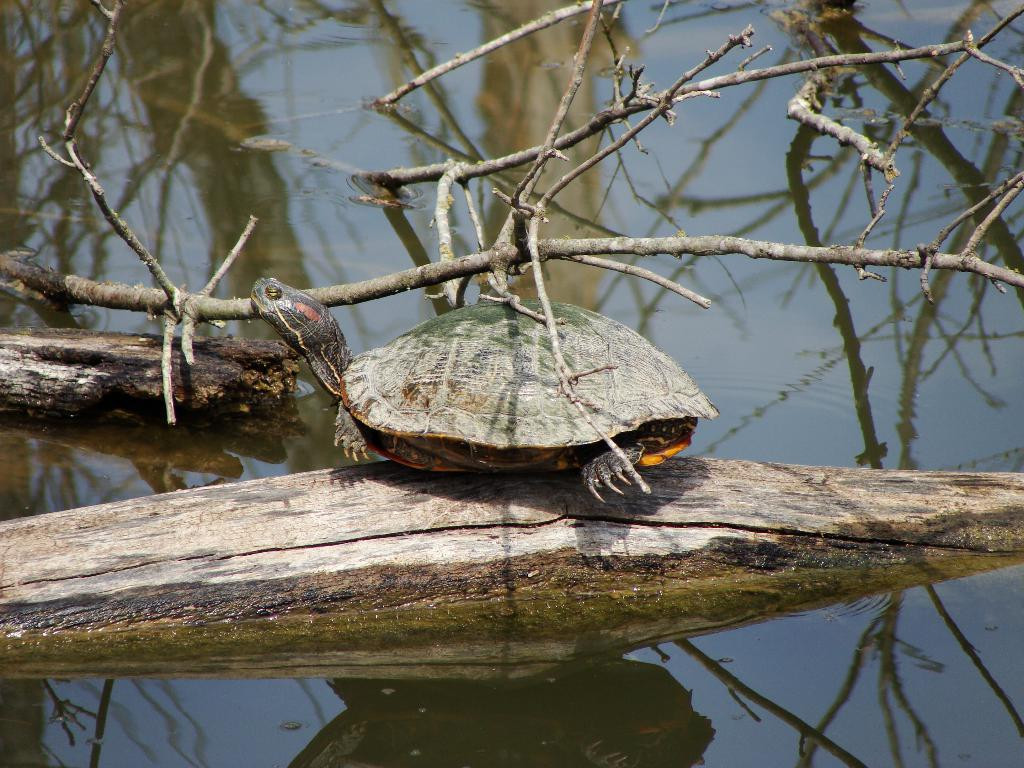What animal is present in the image? There is a tortoise in the image. What is the tortoise resting on? The tortoise is on a wooden log. What type of vegetation can be seen in the image? There are branches of a tree in the image. Where are the branches located? The branches are in a water body. What type of thread is being used to tie the tortoise to the wooden log? There is no thread present in the image, and the tortoise is not tied to the wooden log. 